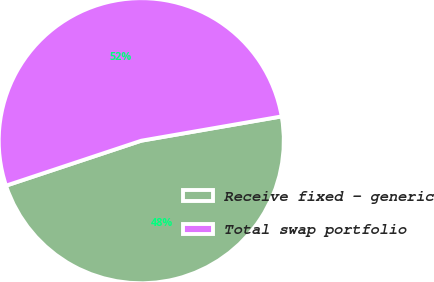Convert chart. <chart><loc_0><loc_0><loc_500><loc_500><pie_chart><fcel>Receive fixed - generic<fcel>Total swap portfolio<nl><fcel>47.62%<fcel>52.38%<nl></chart> 